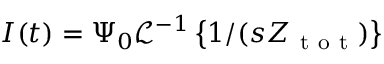Convert formula to latex. <formula><loc_0><loc_0><loc_500><loc_500>I ( t ) = \Psi _ { 0 } \mathcal { L } ^ { - 1 } \left \{ 1 / ( s Z _ { t o t } ) \right \}</formula> 